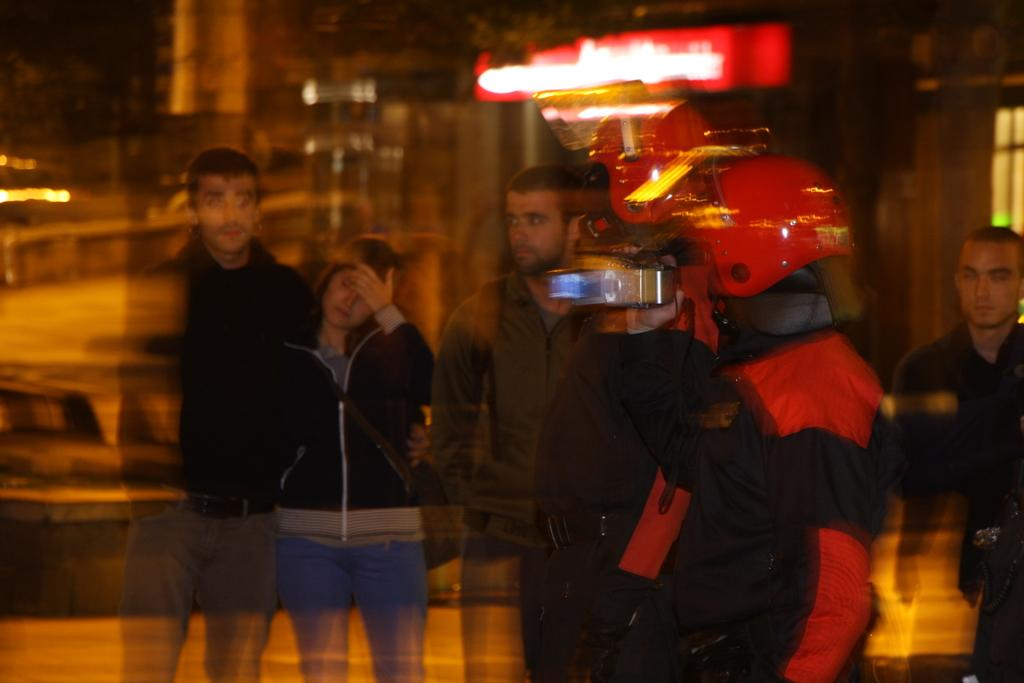How many people are in the image? There is a group of people in the image, but the exact number is not specified. What are the people in the image doing? The group of people are standing. Can you describe any specific object in the image? Yes, there is a red color object in the image. What type of tax is being discussed by the group of people in the image? There is no indication in the image that the group of people are discussing any type of tax. 